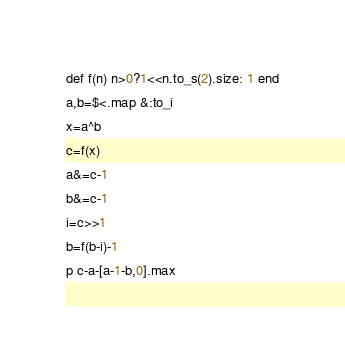<code> <loc_0><loc_0><loc_500><loc_500><_Ruby_>def f(n) n>0?1<<n.to_s(2).size: 1 end
a,b=$<.map &:to_i
x=a^b
c=f(x)
a&=c-1
b&=c-1
i=c>>1
b=f(b-i)-1
p c-a-[a-1-b,0].max</code> 